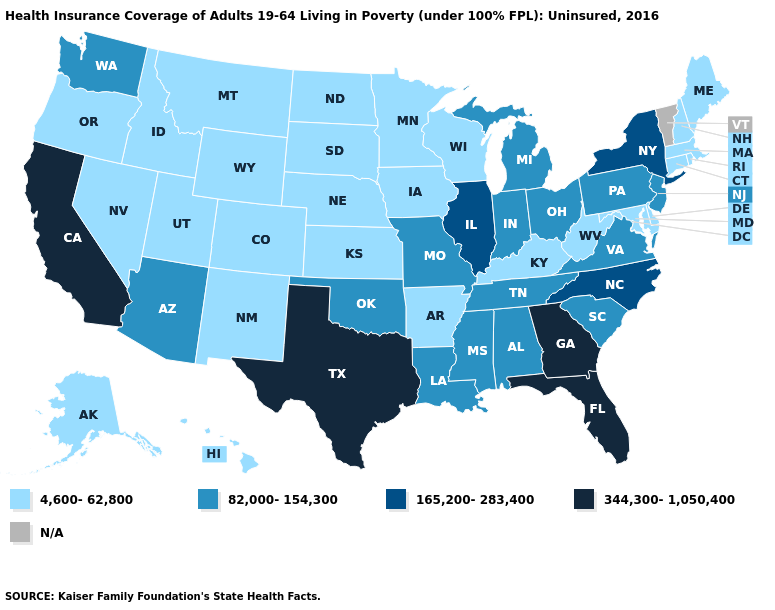Name the states that have a value in the range 165,200-283,400?
Be succinct. Illinois, New York, North Carolina. Name the states that have a value in the range N/A?
Answer briefly. Vermont. What is the value of Massachusetts?
Concise answer only. 4,600-62,800. Does the first symbol in the legend represent the smallest category?
Concise answer only. Yes. Which states have the lowest value in the Northeast?
Keep it brief. Connecticut, Maine, Massachusetts, New Hampshire, Rhode Island. Which states have the lowest value in the USA?
Write a very short answer. Alaska, Arkansas, Colorado, Connecticut, Delaware, Hawaii, Idaho, Iowa, Kansas, Kentucky, Maine, Maryland, Massachusetts, Minnesota, Montana, Nebraska, Nevada, New Hampshire, New Mexico, North Dakota, Oregon, Rhode Island, South Dakota, Utah, West Virginia, Wisconsin, Wyoming. Name the states that have a value in the range 165,200-283,400?
Concise answer only. Illinois, New York, North Carolina. What is the highest value in states that border Maryland?
Write a very short answer. 82,000-154,300. What is the highest value in the USA?
Concise answer only. 344,300-1,050,400. What is the lowest value in the West?
Concise answer only. 4,600-62,800. Name the states that have a value in the range N/A?
Write a very short answer. Vermont. What is the lowest value in the Northeast?
Keep it brief. 4,600-62,800. Does the first symbol in the legend represent the smallest category?
Quick response, please. Yes. What is the lowest value in states that border Nevada?
Keep it brief. 4,600-62,800. 